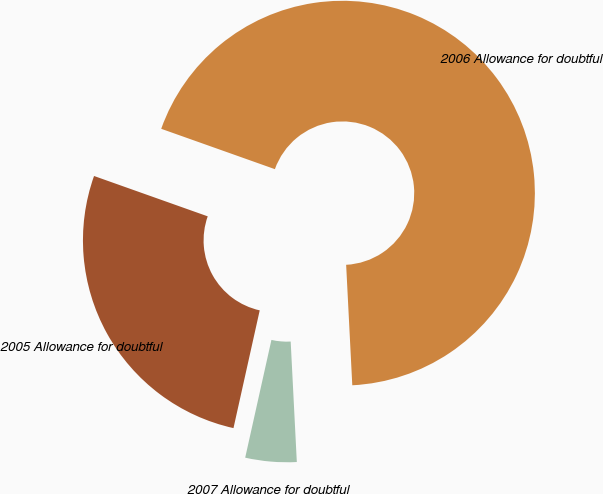<chart> <loc_0><loc_0><loc_500><loc_500><pie_chart><fcel>2007 Allowance for doubtful<fcel>2006 Allowance for doubtful<fcel>2005 Allowance for doubtful<nl><fcel>4.3%<fcel>68.76%<fcel>26.94%<nl></chart> 